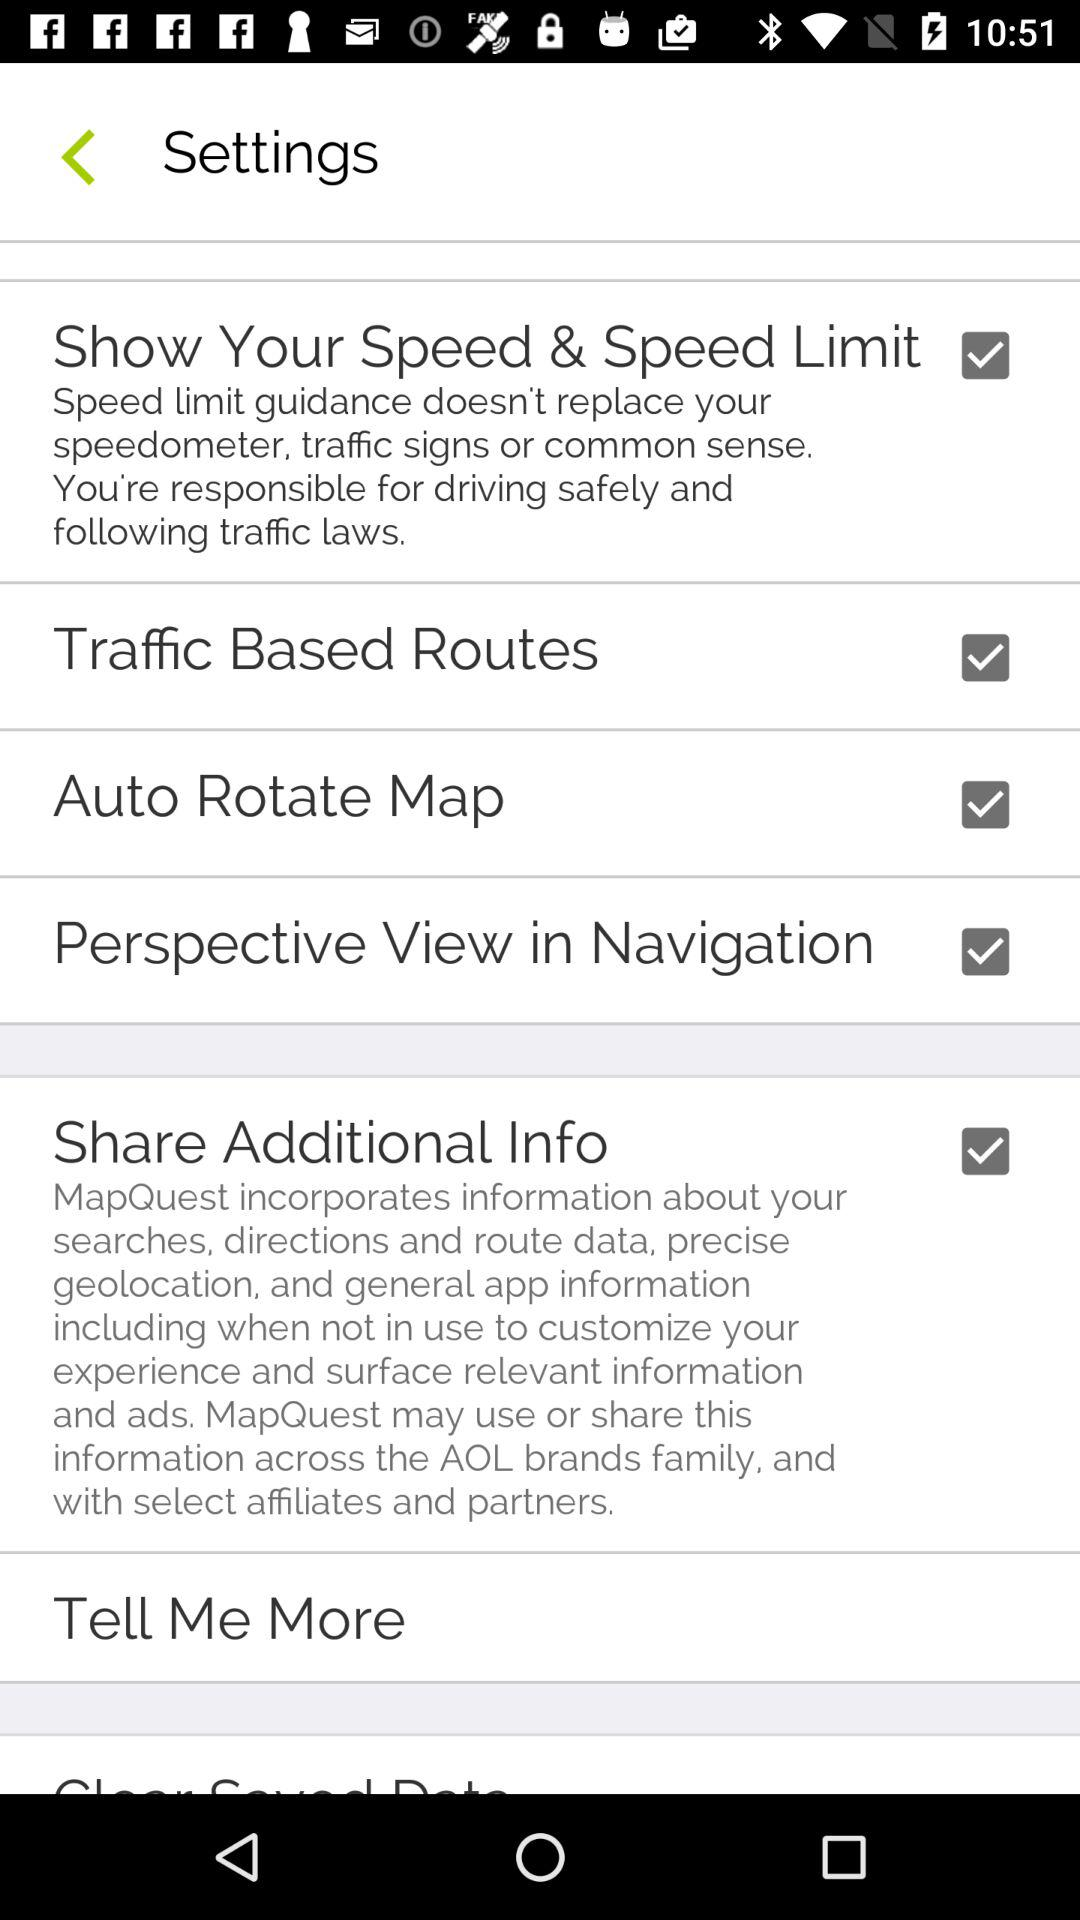What is the status of the "Auto Rotate Map"? The status is "on". 